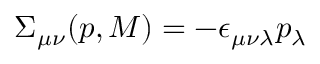<formula> <loc_0><loc_0><loc_500><loc_500>\Sigma _ { \mu \nu } ( p , M ) = - \epsilon _ { \mu \nu \lambda } p _ { \lambda }</formula> 